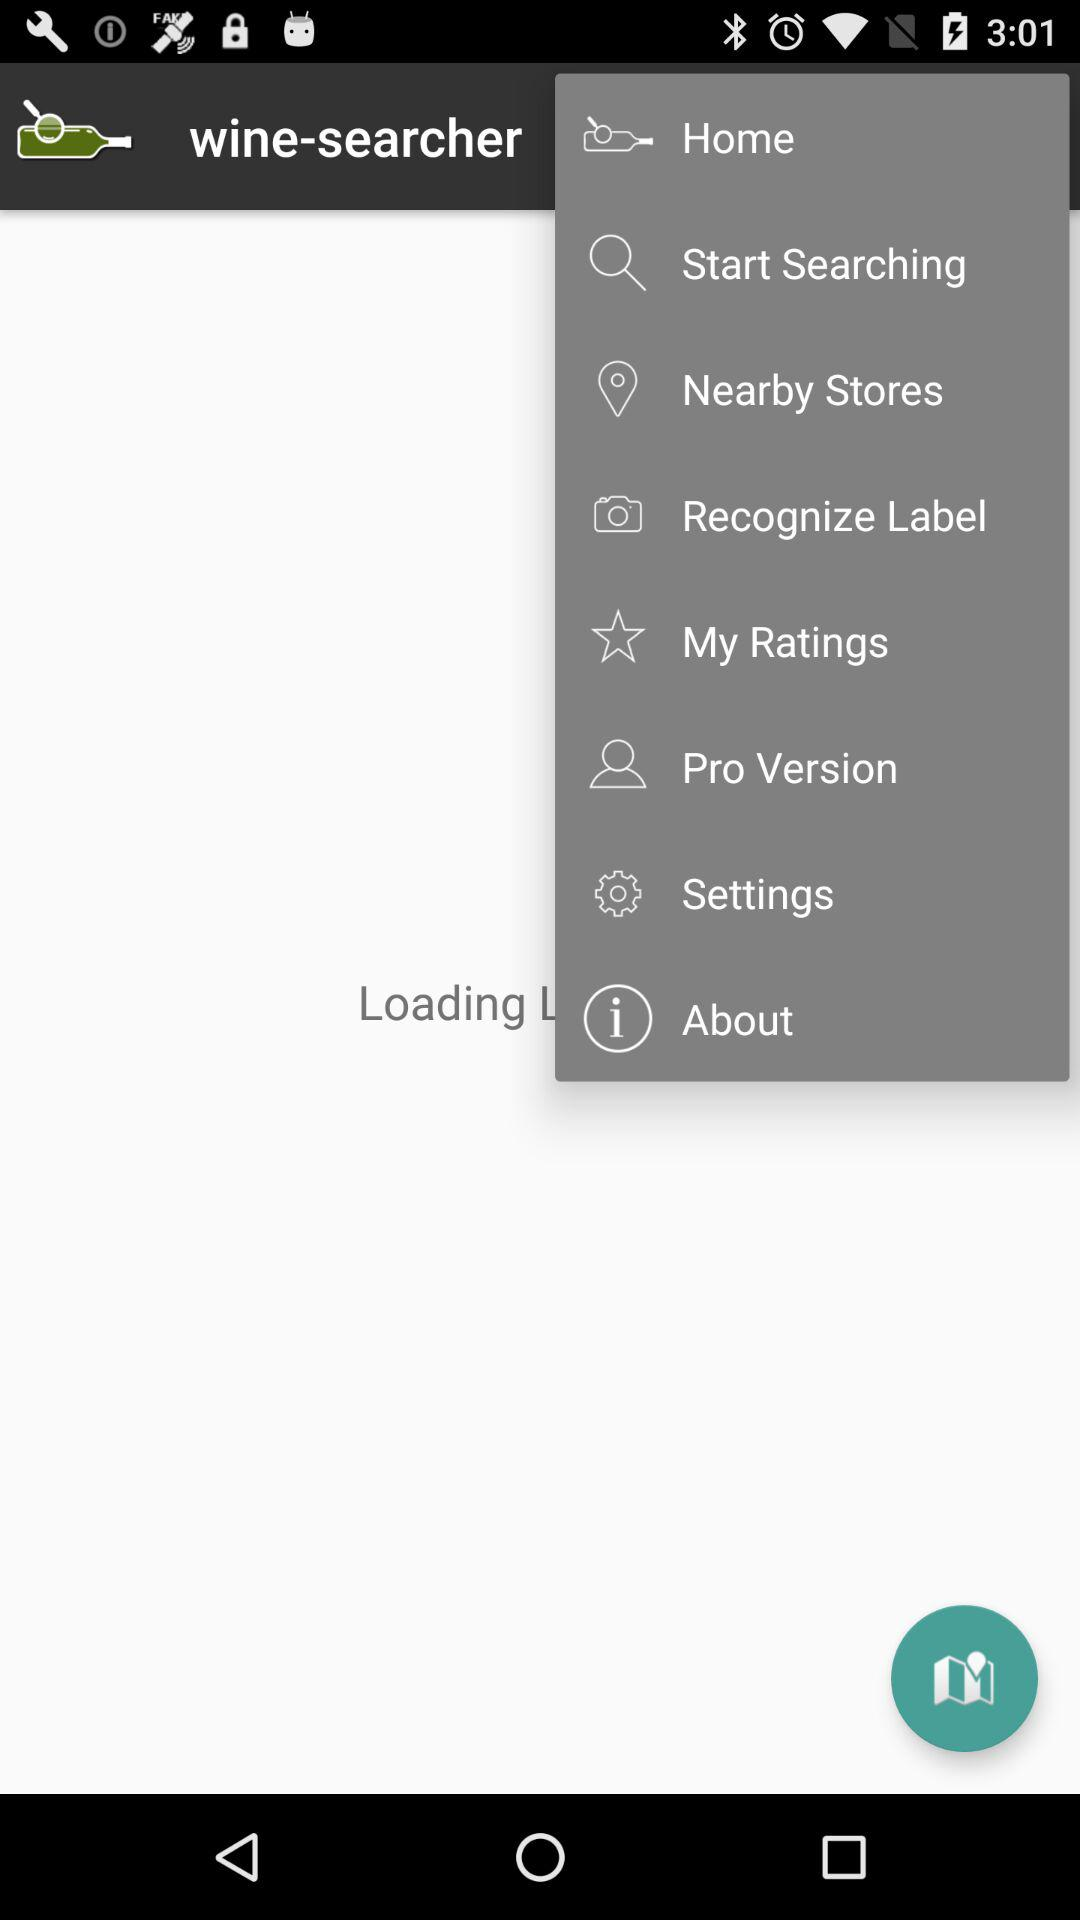What is the application name? The application name is "wine-searcher". 